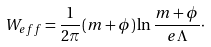Convert formula to latex. <formula><loc_0><loc_0><loc_500><loc_500>W _ { e f f } = \frac { 1 } { 2 \pi } ( m + \phi ) \ln \frac { m + \phi } { e \Lambda } \cdot</formula> 